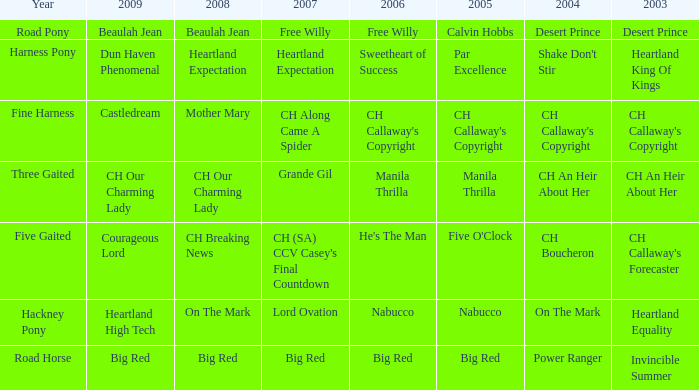What is the 2007 with ch callaway's copyright in 2003? CH Along Came A Spider. 